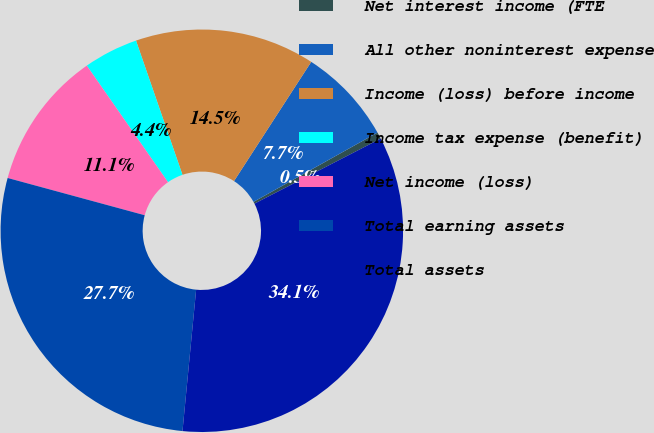<chart> <loc_0><loc_0><loc_500><loc_500><pie_chart><fcel>Net interest income (FTE<fcel>All other noninterest expense<fcel>Income (loss) before income<fcel>Income tax expense (benefit)<fcel>Net income (loss)<fcel>Total earning assets<fcel>Total assets<nl><fcel>0.54%<fcel>7.74%<fcel>14.45%<fcel>4.38%<fcel>11.09%<fcel>27.69%<fcel>34.1%<nl></chart> 